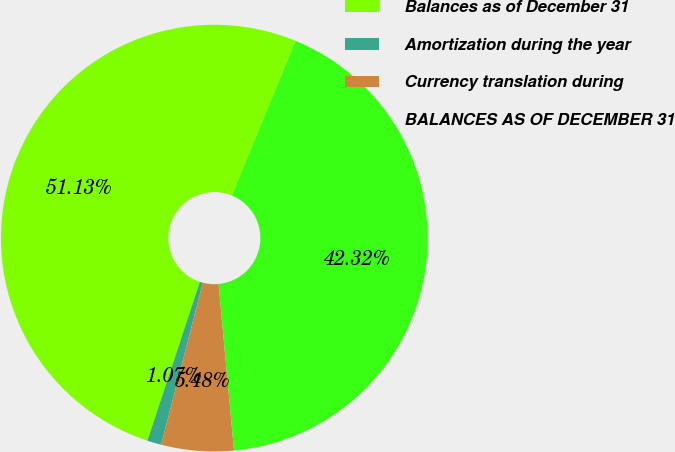Convert chart to OTSL. <chart><loc_0><loc_0><loc_500><loc_500><pie_chart><fcel>Balances as of December 31<fcel>Amortization during the year<fcel>Currency translation during<fcel>BALANCES AS OF DECEMBER 31<nl><fcel>51.14%<fcel>1.07%<fcel>5.48%<fcel>42.32%<nl></chart> 